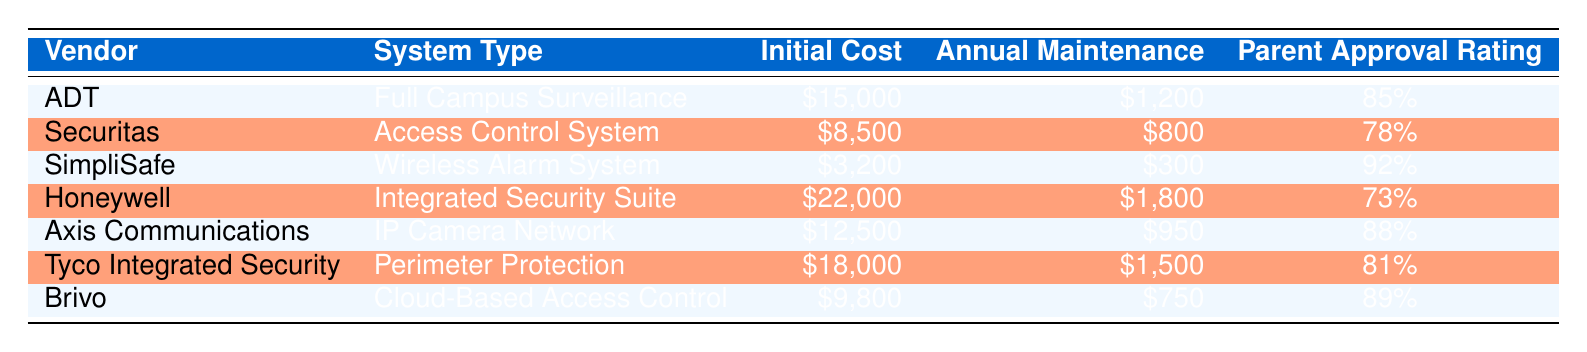What is the initial cost of the SimpliSafe system? The table indicates that the initial cost for the SimpliSafe system is clearly listed under the "Initial Cost" column, which shows "$3,200."
Answer: $3,200 Which vendor has the highest parent approval rating? By comparing the "Parent Approval Rating" values, the highest rating of 92% corresponds to SimpliSafe.
Answer: SimpliSafe What is the total initial cost of the ADT and Brivo systems? The initial cost of ADT is $15,000, and Brivo is $9,800. Adding these two amounts together gives $15,000 + $9,800 = $24,800.
Answer: $24,800 Is the annual maintenance cost for Honeywell higher than that of Axis Communications? The annual maintenance cost for Honeywell is $1,800, while for Axis Communications, it is $950. Since $1,800 is greater than $950, the statement is true.
Answer: Yes What is the average parent approval rating of the systems listed? The parent approval ratings are 85%, 78%, 92%, 73%, 88%, 81%, and 89%. First, we sum these values: 85 + 78 + 92 + 73 + 88 + 81 + 89 = 506. There are 7 ratings, so we divide: 506 / 7 = approximately 72.29%.
Answer: 72.29% Which system has the lowest initial cost? By examining the "Initial Cost" column, the lowest value is for the SimpliSafe system, which is listed as "$3,200."
Answer: SimpliSafe Is Securitas's parent approval rating above 80%? The parent approval rating for Securitas is listed as 78%. Since 78% is not greater than 80%, the statement is false.
Answer: No What is the difference in initial cost between the Integrated Security Suite and the Wireless Alarm System? The initial cost for Honeywell's Integrated Security Suite is $22,000 and for SimpliSafe's Wireless Alarm System it is $3,200. To find the difference, we subtract: $22,000 - $3,200 = $18,800.
Answer: $18,800 